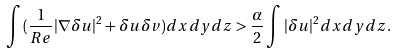<formula> <loc_0><loc_0><loc_500><loc_500>\int { ( \frac { 1 } { R e } | \nabla \delta u | ^ { 2 } + \delta u \delta v ) d x d y d z } > \frac { \alpha } { 2 } \int { | \delta u | ^ { 2 } d x d y d z } .</formula> 